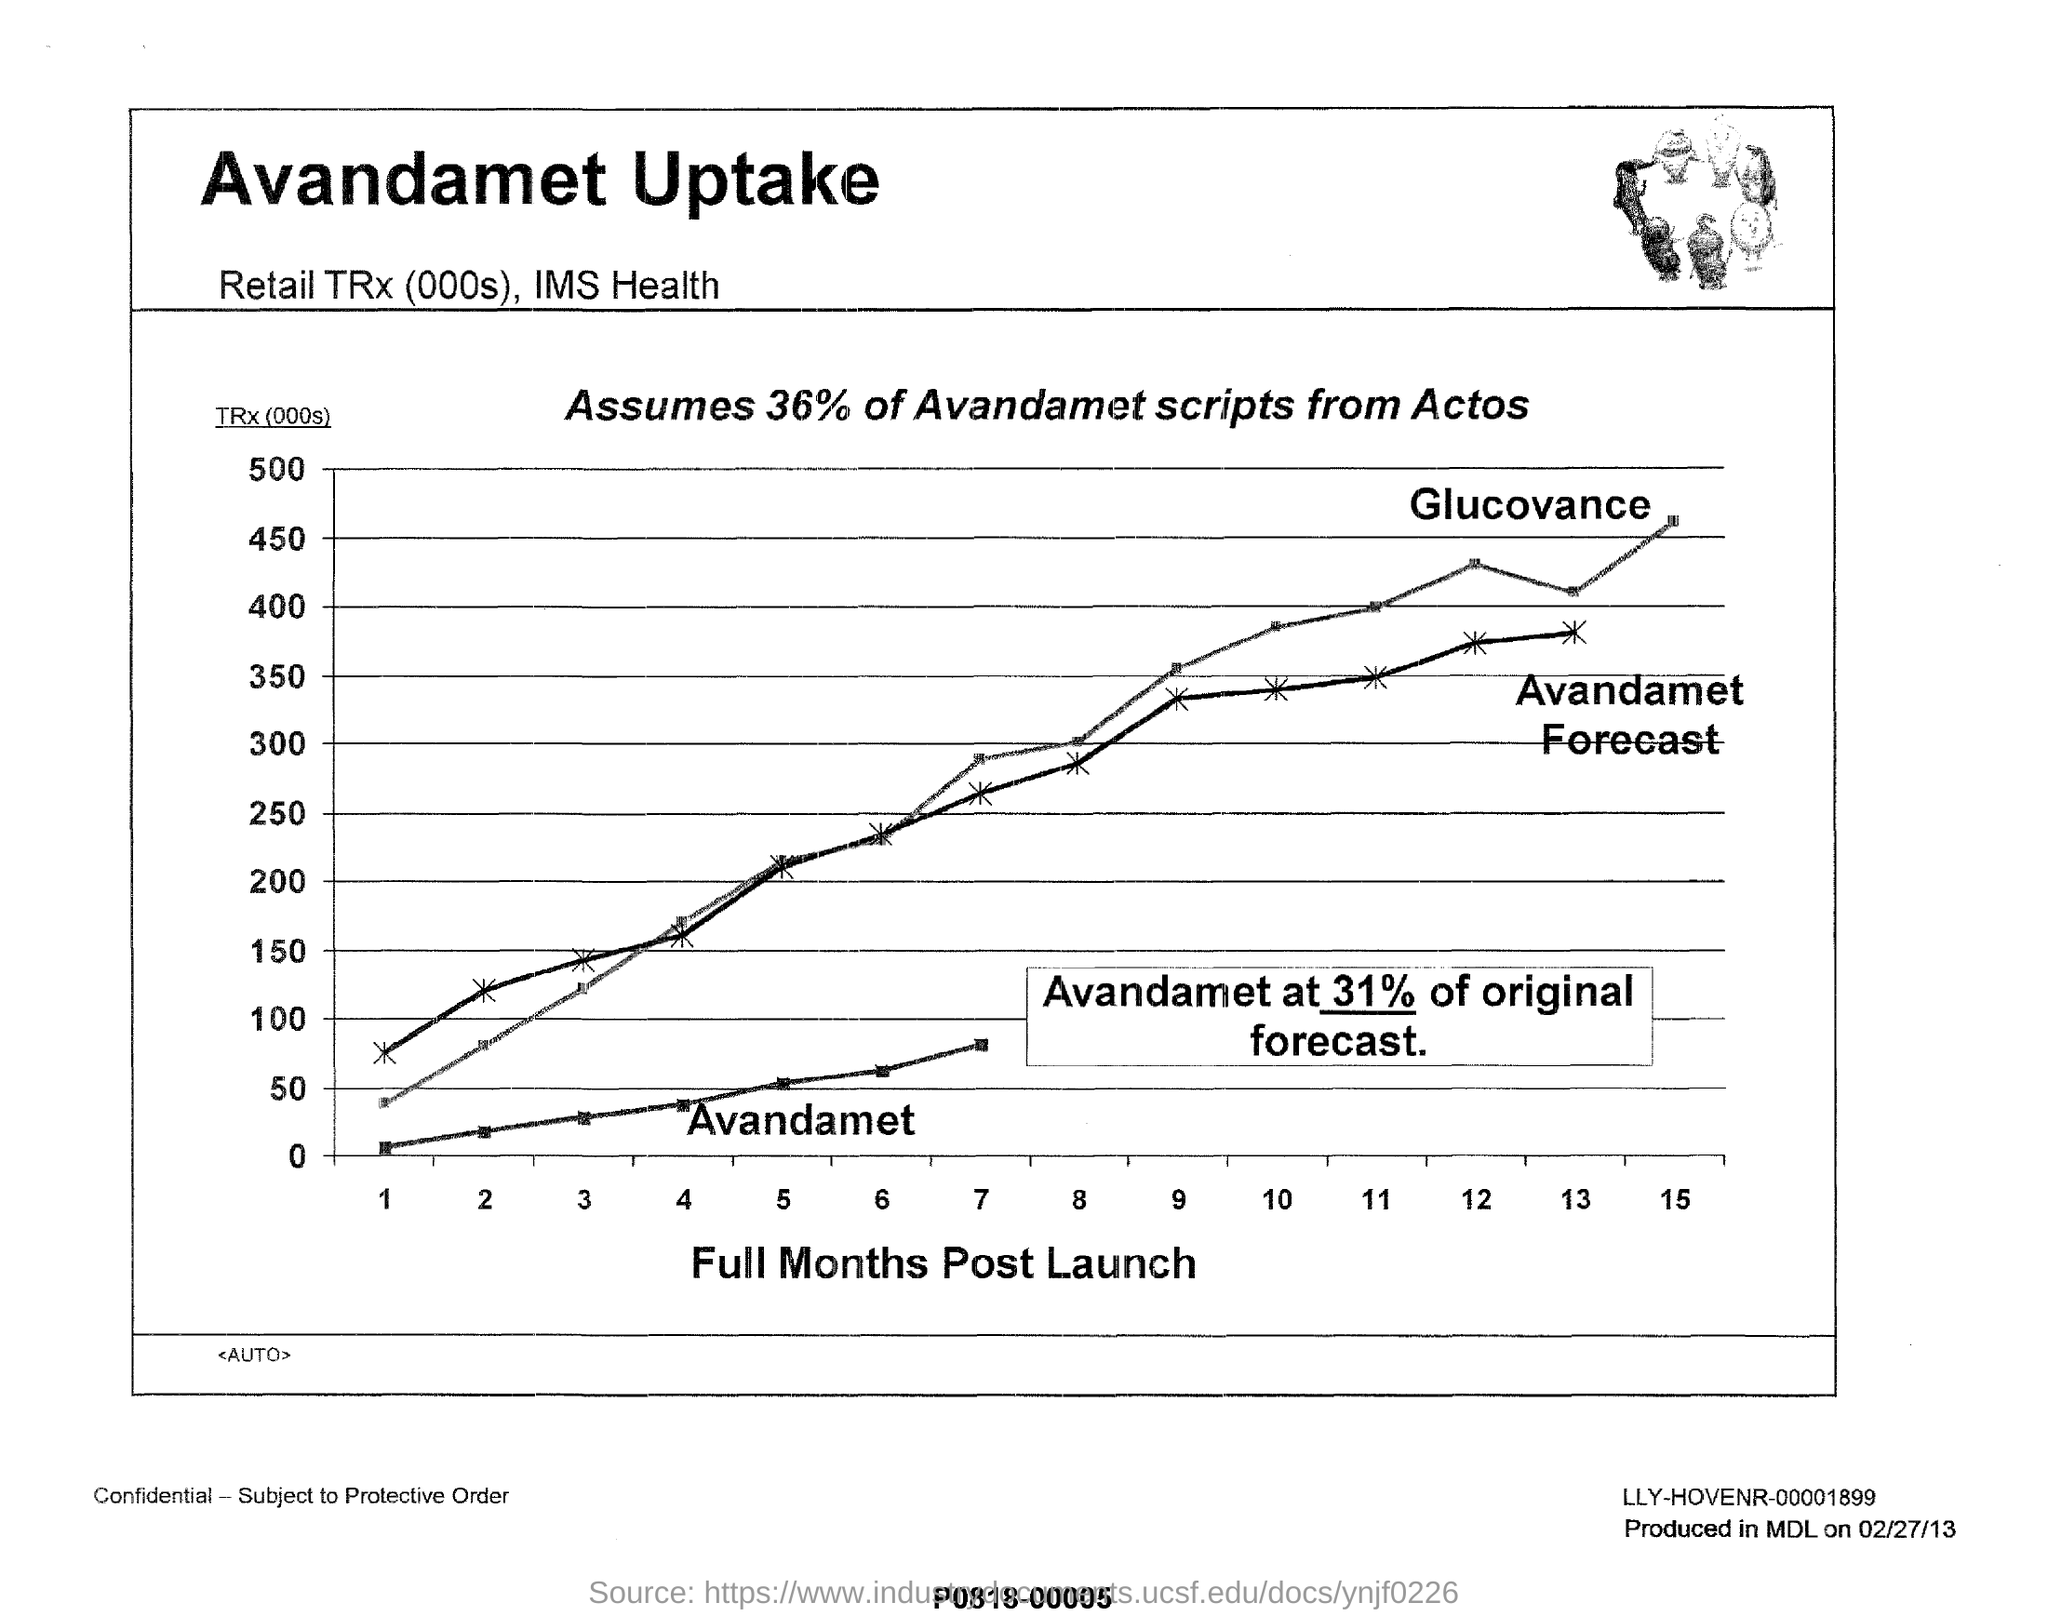What is the heading of this document, given at the top?
Your answer should be very brief. Avandamet Uptake. What are shown on the x-axis?
Ensure brevity in your answer.  FULL MONTHS POST LAUNCH. What is the percentage of Avandamet scripts from Actos mentioned?
Give a very brief answer. 36. What is on the horizonal axis of the graph?
Your answer should be very brief. Full Months Post Launch. 